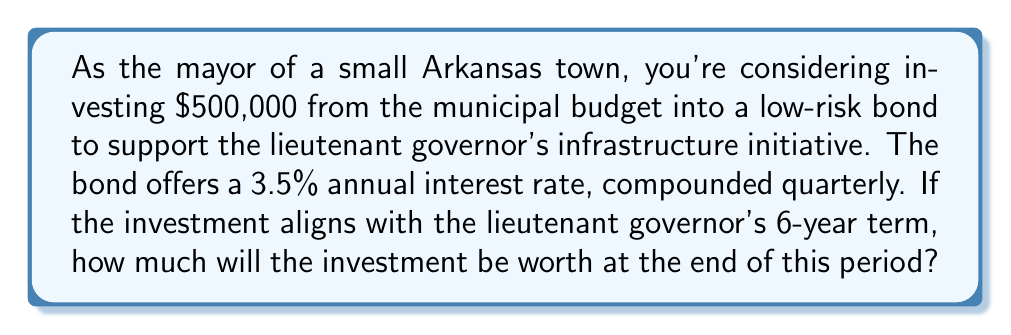Give your solution to this math problem. Let's approach this step-by-step using the compound interest formula:

1) The compound interest formula is:
   $$A = P(1 + \frac{r}{n})^{nt}$$
   Where:
   $A$ = final amount
   $P$ = principal (initial investment)
   $r$ = annual interest rate (as a decimal)
   $n$ = number of times interest is compounded per year
   $t$ = number of years

2) We know:
   $P = \$500,000$
   $r = 3.5\% = 0.035$
   $n = 4$ (compounded quarterly)
   $t = 6$ years

3) Let's substitute these values into the formula:
   $$A = 500,000(1 + \frac{0.035}{4})^{4 \times 6}$$

4) Simplify inside the parentheses:
   $$A = 500,000(1 + 0.00875)^{24}$$

5) Calculate the power:
   $$A = 500,000(1.00875)^{24} \approx 500,000 \times 1.231564$$

6) Multiply:
   $$A \approx 615,782$$

Therefore, after 6 years, the investment will be worth approximately $615,782.
Answer: $615,782 